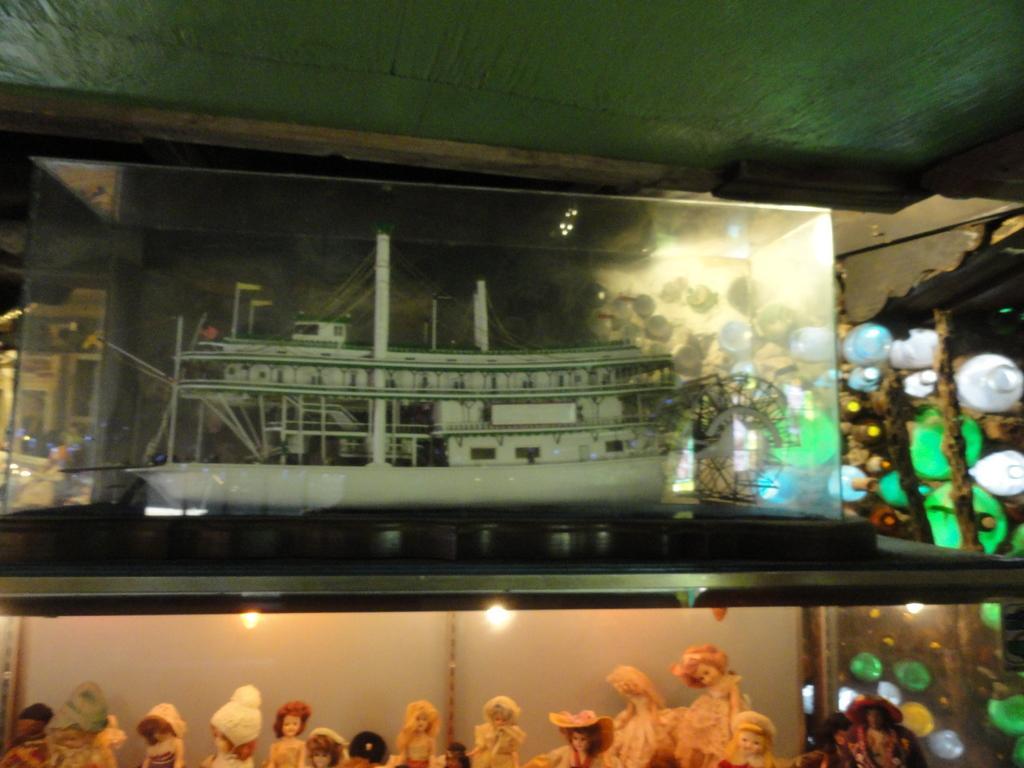Please provide a concise description of this image. In this image we can see some dolls, water bottles, painting of a ship and top of the image there is green color sheet. 